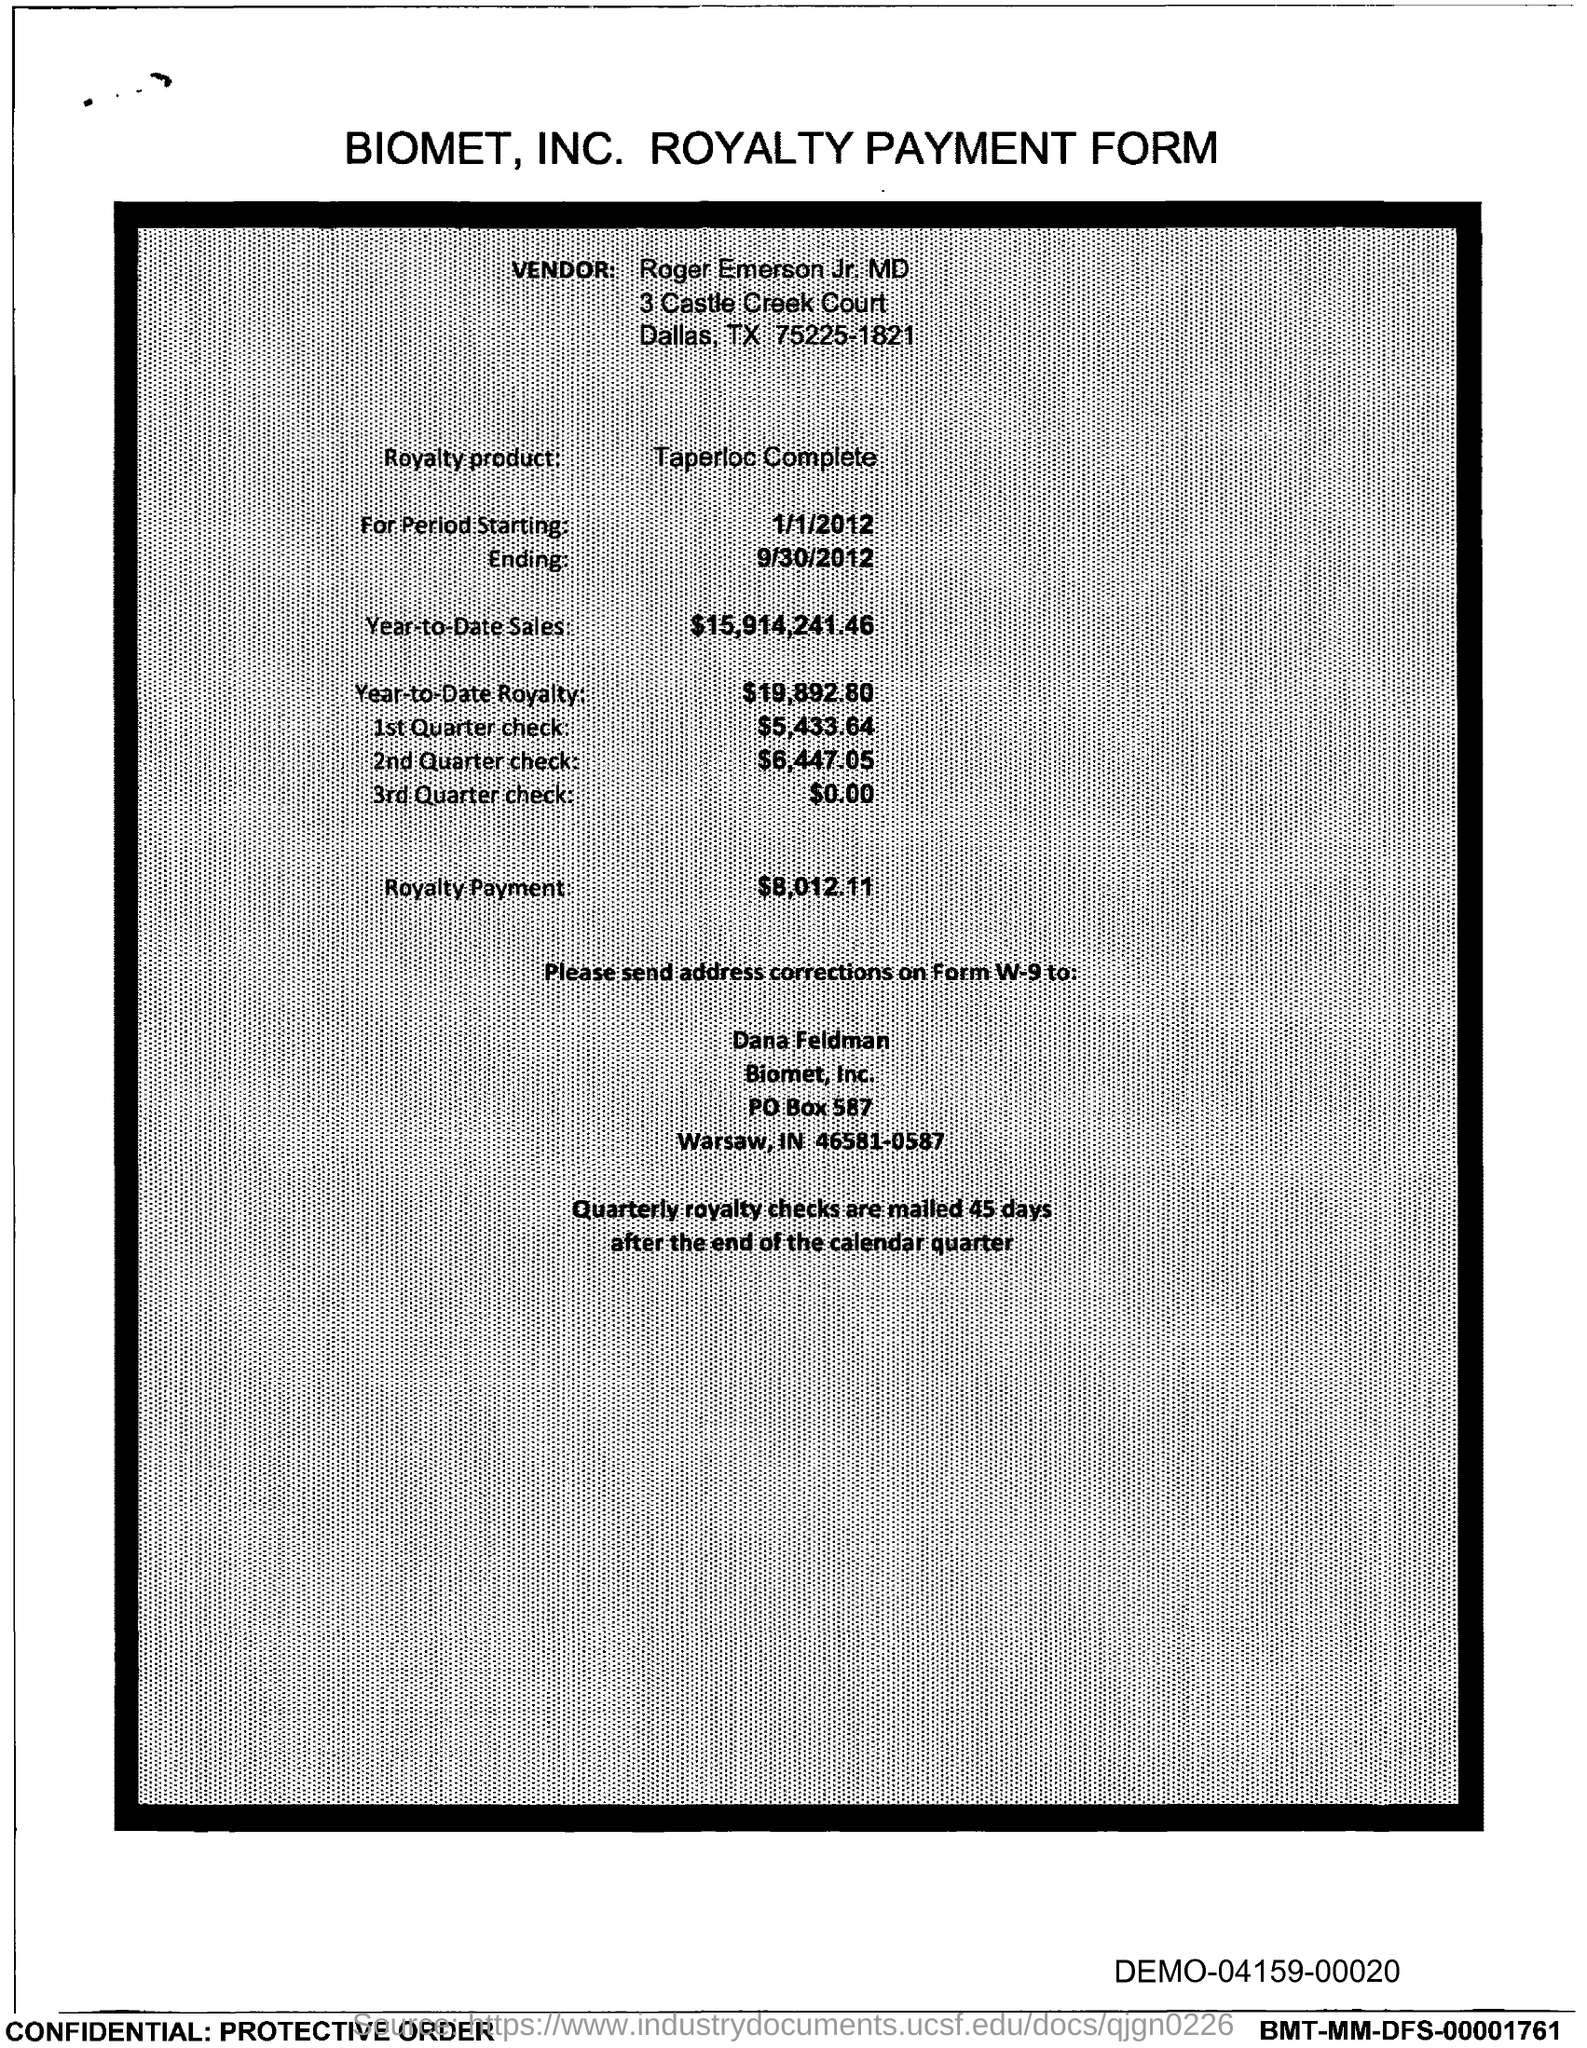Draw attention to some important aspects in this diagram. The vendor name mentioned in this form is Roger Emerson Jr. MD. Year-to-date sales, as mentioned in this document, are $15,914,241.46. The title of this form is "Biomet, INC. Royalty Payment Form. 